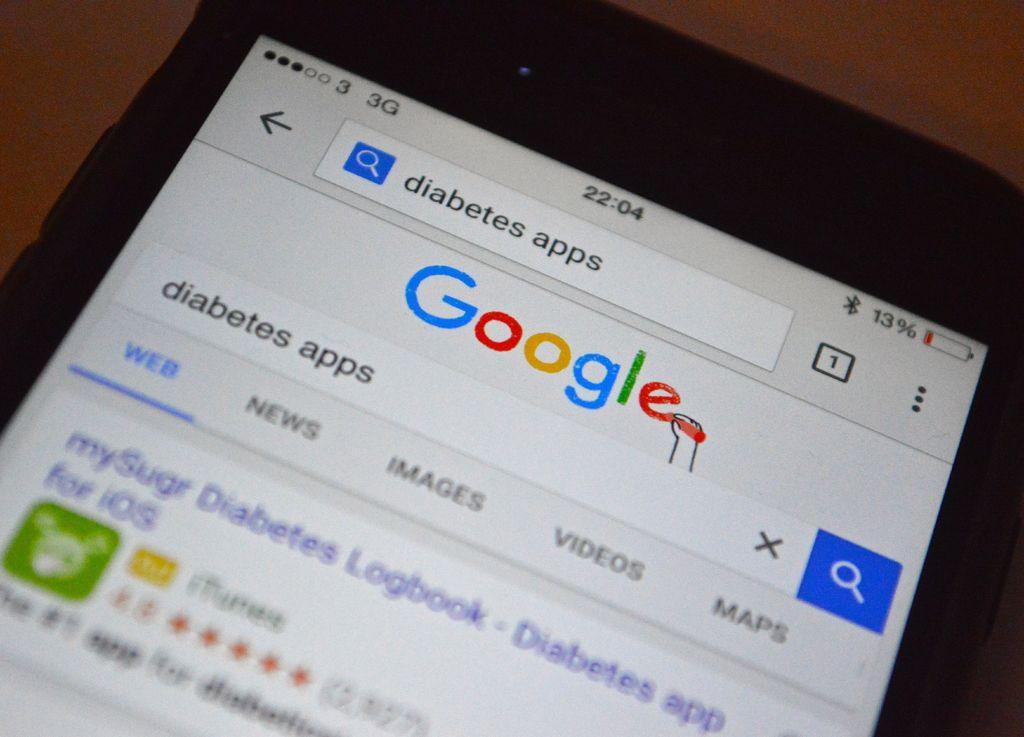What is being searched on google?
Keep it short and to the point. Diabetes apps. 